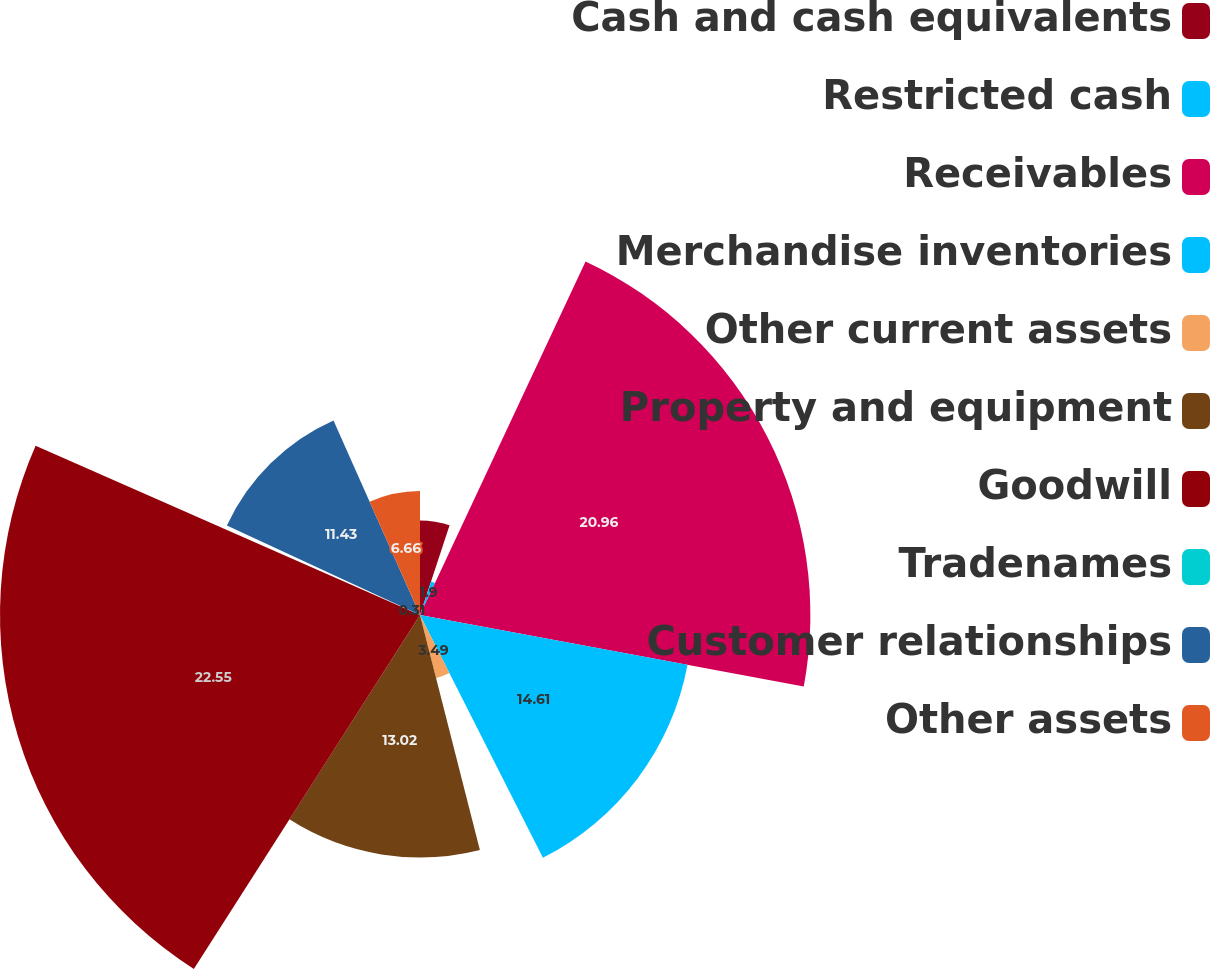<chart> <loc_0><loc_0><loc_500><loc_500><pie_chart><fcel>Cash and cash equivalents<fcel>Restricted cash<fcel>Receivables<fcel>Merchandise inventories<fcel>Other current assets<fcel>Property and equipment<fcel>Goodwill<fcel>Tradenames<fcel>Customer relationships<fcel>Other assets<nl><fcel>5.07%<fcel>1.9%<fcel>20.96%<fcel>14.61%<fcel>3.49%<fcel>13.02%<fcel>22.55%<fcel>0.31%<fcel>11.43%<fcel>6.66%<nl></chart> 